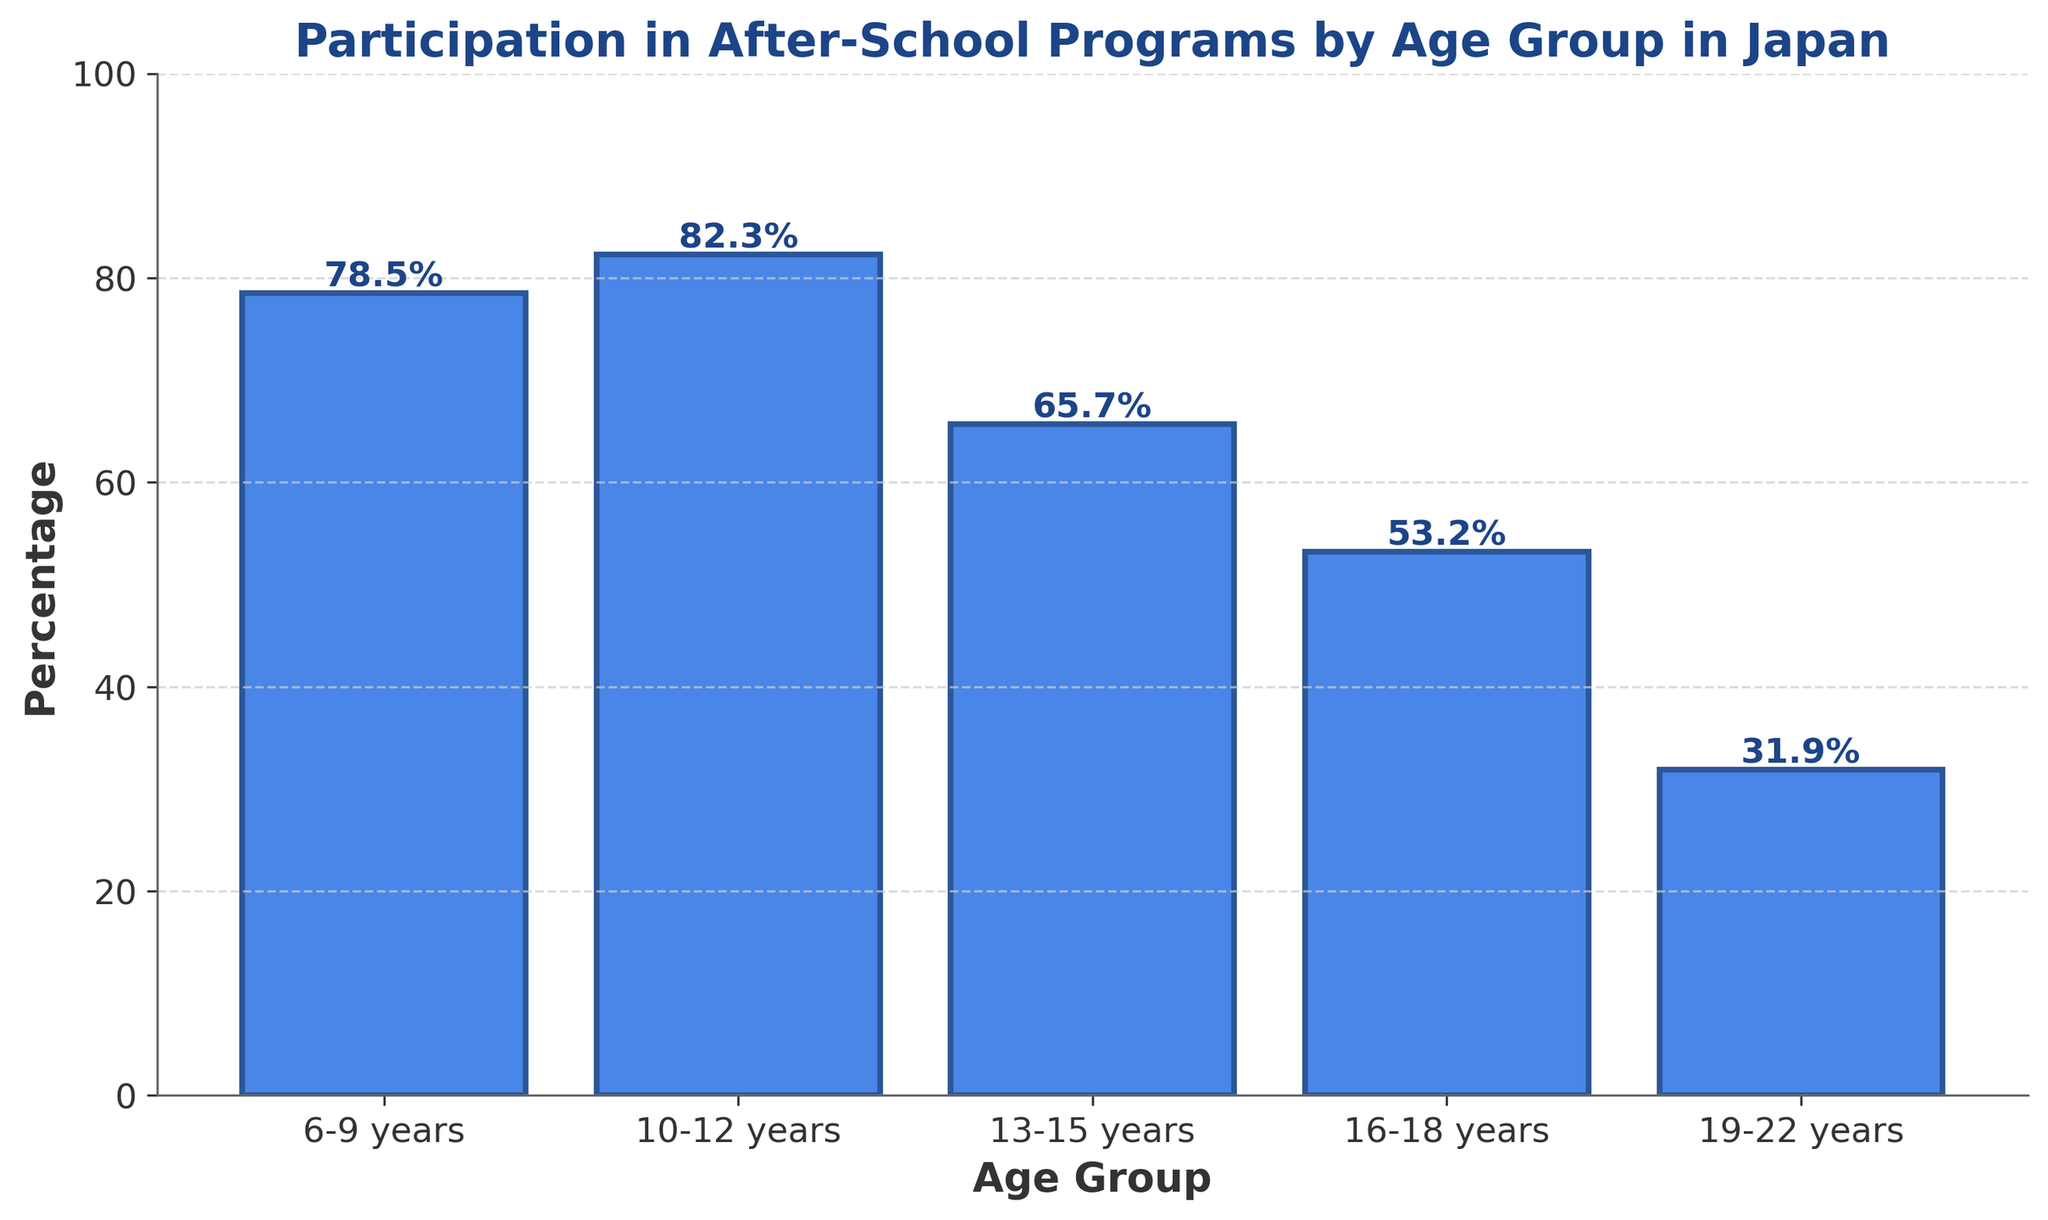What's the percentage of 16-18 year olds participating in after-school programs? The bar corresponding to the age group 16-18 years shows a height that represents the percentage.
Answer: 53.2% Which age group has the highest participation in after-school programs? To find this, look at the heights of the bars to determine which one is the tallest. The bar for the 10-12 years group is the tallest.
Answer: 10-12 years What is the difference in participation between 13-15 year olds and 19-22 year olds? Subtract the percentage for 19-22 years (31.9) from the percentage for 13-15 years (65.7). 65.7 - 31.9 = 33.8
Answer: 33.8% Which age group shows the most significant drop in participation compared to its preceding age group? Compare the differences in percentages between each consecutive age group: 
- 6-9 to 10-12: 82.3 - 78.5 = 3.8
- 10-12 to 13-15: 82.3 - 65.7 = 16.6
- 13-15 to 16-18: 65.7 - 53.2 = 12.5
- 16-18 to 19-22: 53.2 - 31.9 = 21.3
The largest drop is from the 16-18 to 19-22 age group.
Answer: 16-18 to 19-22 How much higher is the participation rate for 10-12 year olds compared to 6-9 year olds? Subtract the percentage of 6-9 years (78.5) from the percentage of 10-12 years (82.3). 82.3 - 78.5 = 3.8
Answer: 3.8% What is the average percentage of participation for the age groups 6-9, 10-12, and 13-15 years? Add the percentages and divide by the number of groups: (78.5 + 82.3 + 65.7) / 3 = 226.5 / 3 = 75.5
Answer: 75.5% Which age group has the lowest participation in after-school programs? Identify the shortest bar, which corresponds to the 19-22 years group.
Answer: 19-22 years What is the total participation percentage when combining the 10-12 years and 16-18 years age groups? Add the percentages of 10-12 years (82.3) and 16-18 years (53.2). 82.3 + 53.2 = 135.5
Answer: 135.5% How does the participation rate for 13-15 year olds compare to the participation rate for 6-9 year olds? Subtract the percentage of 13-15 years (65.7) from the percentage of 6-9 years (78.5). 78.5 - 65.7 = 12.8, meaning 6-9 years have a 12.8 percentage points higher participation rate.
Answer: 12.8% more 